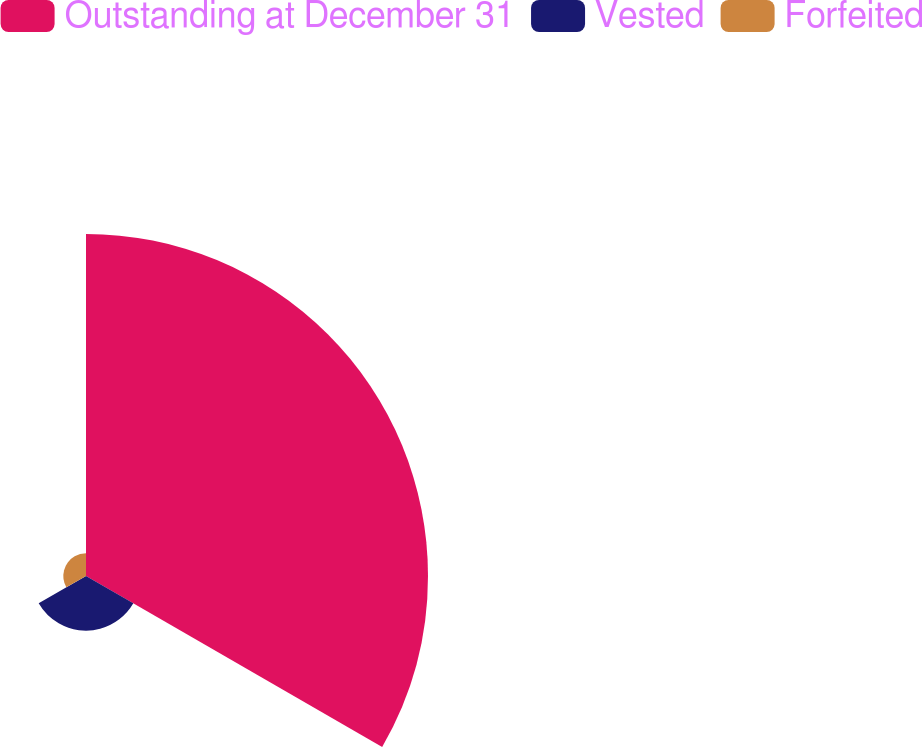Convert chart to OTSL. <chart><loc_0><loc_0><loc_500><loc_500><pie_chart><fcel>Outstanding at December 31<fcel>Vested<fcel>Forfeited<nl><fcel>81.56%<fcel>13.03%<fcel>5.41%<nl></chart> 